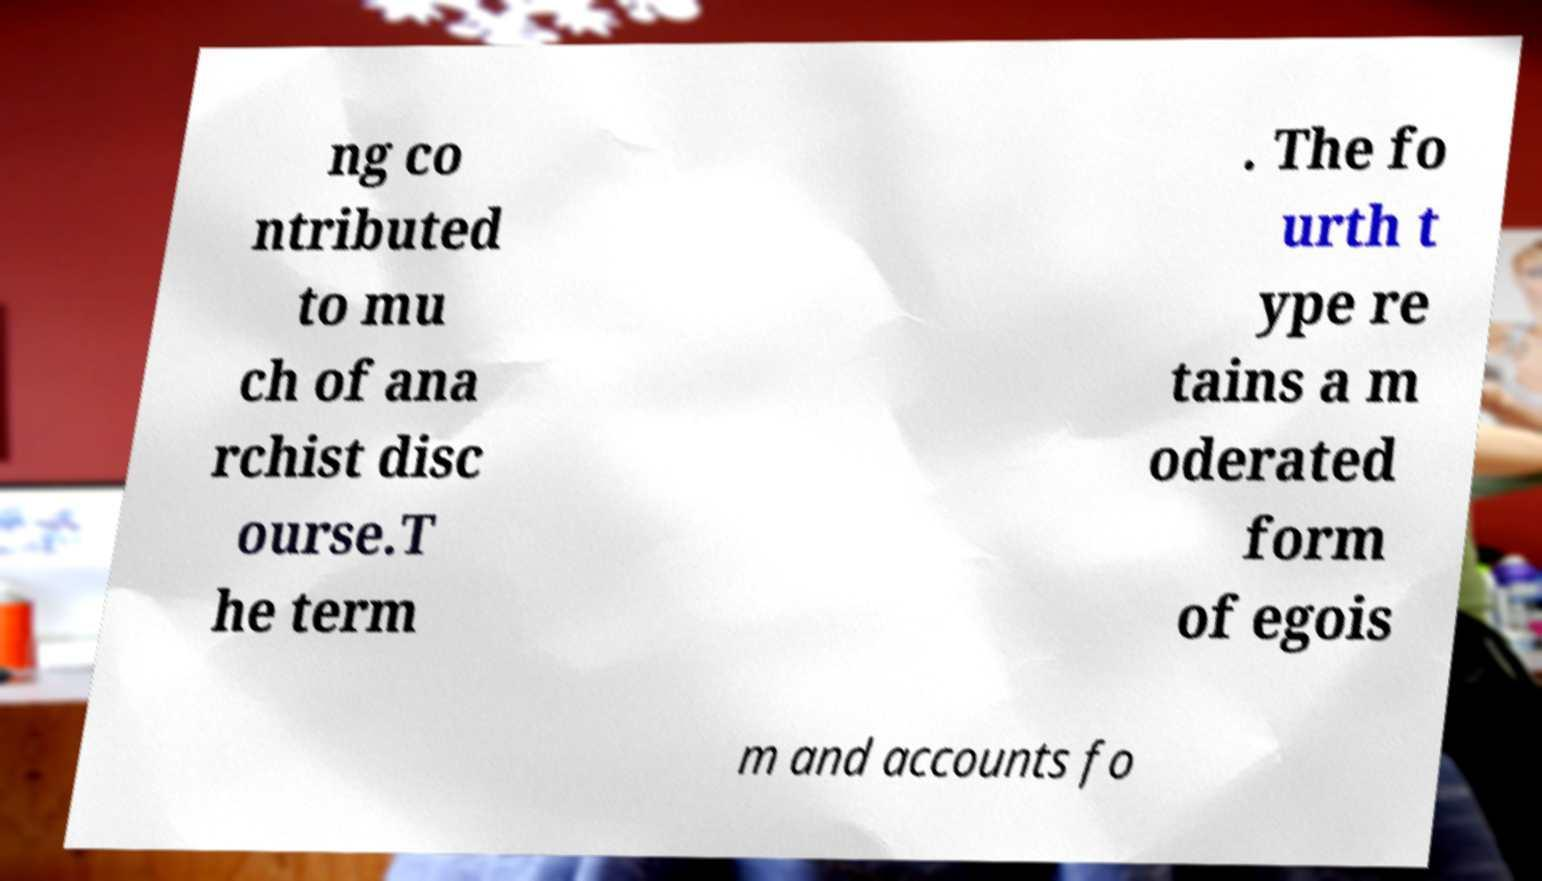Please read and relay the text visible in this image. What does it say? ng co ntributed to mu ch of ana rchist disc ourse.T he term . The fo urth t ype re tains a m oderated form of egois m and accounts fo 